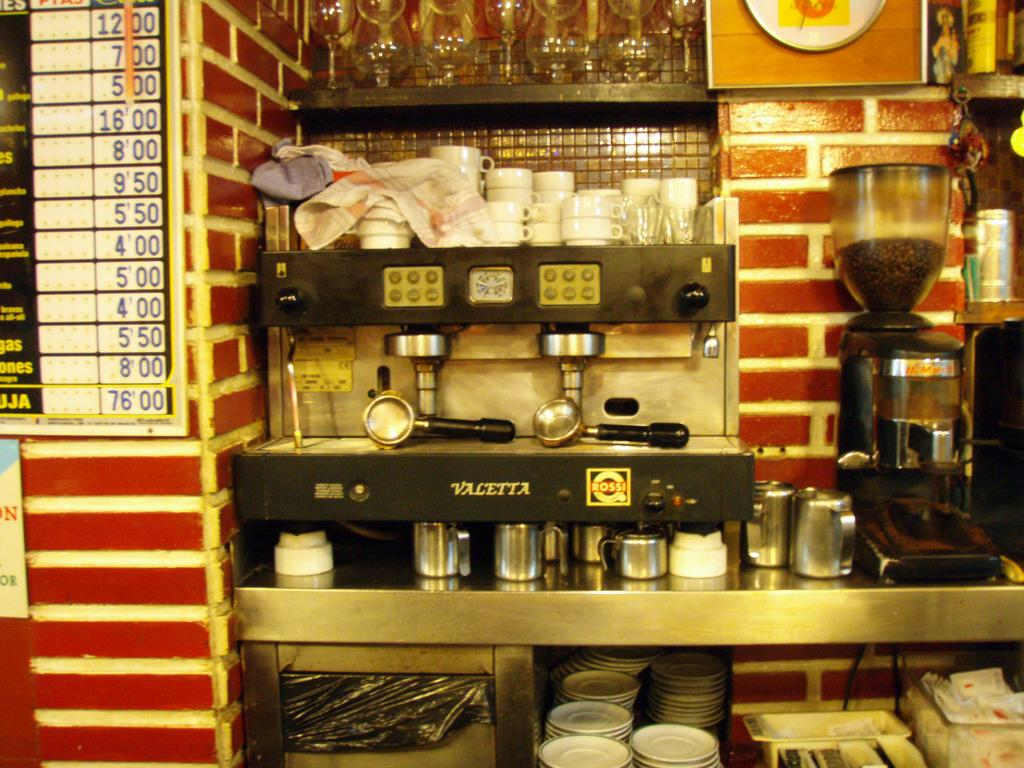<image>
Provide a brief description of the given image. An coffee shop with a Valetta espresso machine. 